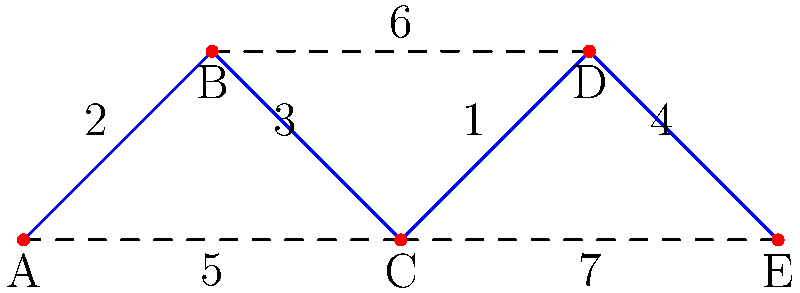Given the graph representing genetic distances between species A, B, C, D, and E, what is the total genetic distance in the minimum spanning tree? To find the minimum spanning tree and calculate the total genetic distance:

1. Identify all edges and their weights:
   AB: 2, BC: 3, CD: 1, DE: 4, AC: 5, BD: 6, CE: 7

2. Sort edges by weight in ascending order:
   CD: 1, AB: 2, BC: 3, DE: 4, AC: 5, BD: 6, CE: 7

3. Apply Kruskal's algorithm:
   a. Add CD (1)
   b. Add AB (2)
   c. Add BC (3)
   d. Add DE (4)

4. The minimum spanning tree consists of edges: CD, AB, BC, DE

5. Calculate total genetic distance:
   Total = 1 + 2 + 3 + 4 = 10

Therefore, the total genetic distance in the minimum spanning tree is 10.
Answer: 10 